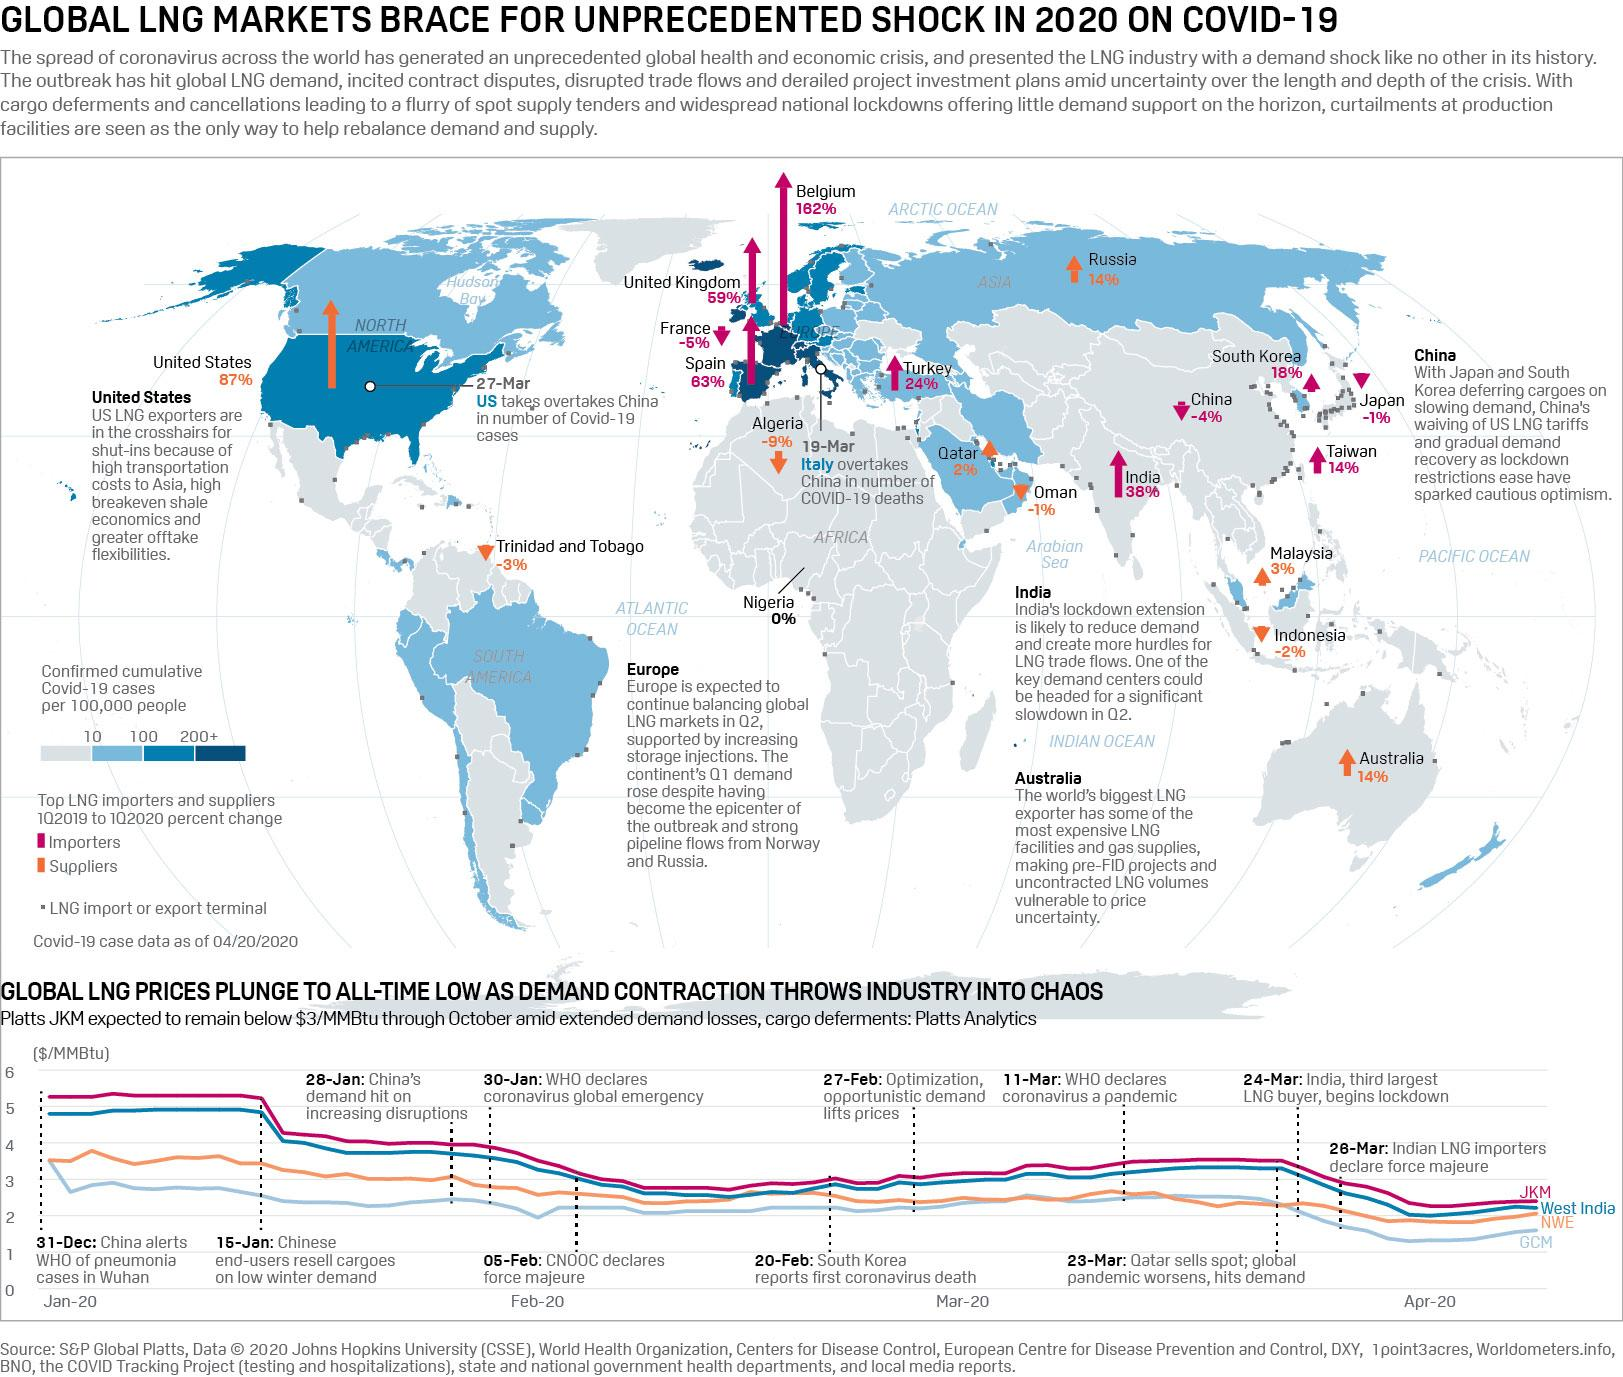Point out several critical features in this image. On January 30, the World Health Organization declared a global emergency in response to the ongoing COVID-19 pandemic. The World Health Organization declared the COVID-19 pandemic on March 11, 2020. 